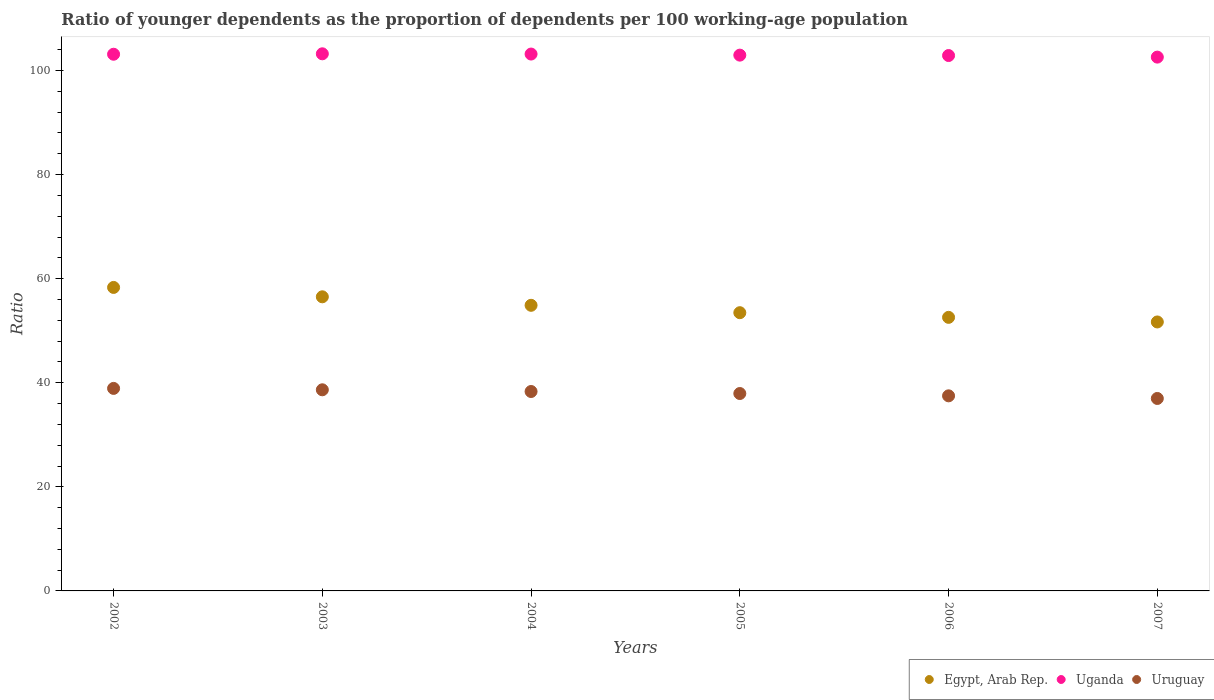Is the number of dotlines equal to the number of legend labels?
Provide a succinct answer. Yes. What is the age dependency ratio(young) in Uganda in 2006?
Offer a terse response. 102.87. Across all years, what is the maximum age dependency ratio(young) in Egypt, Arab Rep.?
Your response must be concise. 58.31. Across all years, what is the minimum age dependency ratio(young) in Egypt, Arab Rep.?
Your response must be concise. 51.68. In which year was the age dependency ratio(young) in Uruguay maximum?
Offer a very short reply. 2002. What is the total age dependency ratio(young) in Uruguay in the graph?
Make the answer very short. 228.27. What is the difference between the age dependency ratio(young) in Uganda in 2004 and that in 2005?
Offer a terse response. 0.21. What is the difference between the age dependency ratio(young) in Egypt, Arab Rep. in 2004 and the age dependency ratio(young) in Uruguay in 2007?
Give a very brief answer. 17.9. What is the average age dependency ratio(young) in Egypt, Arab Rep. per year?
Give a very brief answer. 54.57. In the year 2005, what is the difference between the age dependency ratio(young) in Uganda and age dependency ratio(young) in Uruguay?
Offer a terse response. 65.02. What is the ratio of the age dependency ratio(young) in Uganda in 2005 to that in 2007?
Keep it short and to the point. 1. What is the difference between the highest and the second highest age dependency ratio(young) in Egypt, Arab Rep.?
Make the answer very short. 1.8. What is the difference between the highest and the lowest age dependency ratio(young) in Uganda?
Your answer should be very brief. 0.63. Is the sum of the age dependency ratio(young) in Egypt, Arab Rep. in 2002 and 2006 greater than the maximum age dependency ratio(young) in Uruguay across all years?
Provide a short and direct response. Yes. Is it the case that in every year, the sum of the age dependency ratio(young) in Egypt, Arab Rep. and age dependency ratio(young) in Uganda  is greater than the age dependency ratio(young) in Uruguay?
Make the answer very short. Yes. How many dotlines are there?
Keep it short and to the point. 3. How many years are there in the graph?
Keep it short and to the point. 6. What is the difference between two consecutive major ticks on the Y-axis?
Your answer should be very brief. 20. Are the values on the major ticks of Y-axis written in scientific E-notation?
Offer a very short reply. No. How are the legend labels stacked?
Make the answer very short. Horizontal. What is the title of the graph?
Give a very brief answer. Ratio of younger dependents as the proportion of dependents per 100 working-age population. Does "Tunisia" appear as one of the legend labels in the graph?
Provide a succinct answer. No. What is the label or title of the X-axis?
Your answer should be very brief. Years. What is the label or title of the Y-axis?
Keep it short and to the point. Ratio. What is the Ratio in Egypt, Arab Rep. in 2002?
Provide a succinct answer. 58.31. What is the Ratio of Uganda in 2002?
Offer a very short reply. 103.12. What is the Ratio in Uruguay in 2002?
Offer a very short reply. 38.91. What is the Ratio of Egypt, Arab Rep. in 2003?
Provide a short and direct response. 56.51. What is the Ratio of Uganda in 2003?
Provide a succinct answer. 103.2. What is the Ratio of Uruguay in 2003?
Ensure brevity in your answer.  38.65. What is the Ratio in Egypt, Arab Rep. in 2004?
Your answer should be compact. 54.88. What is the Ratio of Uganda in 2004?
Offer a terse response. 103.16. What is the Ratio in Uruguay in 2004?
Your answer should be compact. 38.32. What is the Ratio of Egypt, Arab Rep. in 2005?
Provide a succinct answer. 53.46. What is the Ratio in Uganda in 2005?
Provide a short and direct response. 102.95. What is the Ratio in Uruguay in 2005?
Offer a very short reply. 37.93. What is the Ratio in Egypt, Arab Rep. in 2006?
Offer a terse response. 52.56. What is the Ratio in Uganda in 2006?
Provide a succinct answer. 102.87. What is the Ratio of Uruguay in 2006?
Give a very brief answer. 37.49. What is the Ratio of Egypt, Arab Rep. in 2007?
Offer a very short reply. 51.68. What is the Ratio in Uganda in 2007?
Make the answer very short. 102.57. What is the Ratio in Uruguay in 2007?
Your answer should be very brief. 36.98. Across all years, what is the maximum Ratio of Egypt, Arab Rep.?
Provide a succinct answer. 58.31. Across all years, what is the maximum Ratio in Uganda?
Give a very brief answer. 103.2. Across all years, what is the maximum Ratio of Uruguay?
Offer a terse response. 38.91. Across all years, what is the minimum Ratio in Egypt, Arab Rep.?
Offer a terse response. 51.68. Across all years, what is the minimum Ratio of Uganda?
Provide a succinct answer. 102.57. Across all years, what is the minimum Ratio of Uruguay?
Your answer should be very brief. 36.98. What is the total Ratio in Egypt, Arab Rep. in the graph?
Give a very brief answer. 327.41. What is the total Ratio in Uganda in the graph?
Your answer should be very brief. 617.87. What is the total Ratio in Uruguay in the graph?
Provide a short and direct response. 228.27. What is the difference between the Ratio of Egypt, Arab Rep. in 2002 and that in 2003?
Give a very brief answer. 1.8. What is the difference between the Ratio in Uganda in 2002 and that in 2003?
Offer a very short reply. -0.08. What is the difference between the Ratio in Uruguay in 2002 and that in 2003?
Offer a terse response. 0.27. What is the difference between the Ratio of Egypt, Arab Rep. in 2002 and that in 2004?
Make the answer very short. 3.44. What is the difference between the Ratio of Uganda in 2002 and that in 2004?
Ensure brevity in your answer.  -0.03. What is the difference between the Ratio of Uruguay in 2002 and that in 2004?
Provide a succinct answer. 0.6. What is the difference between the Ratio of Egypt, Arab Rep. in 2002 and that in 2005?
Provide a short and direct response. 4.85. What is the difference between the Ratio of Uganda in 2002 and that in 2005?
Offer a terse response. 0.17. What is the difference between the Ratio in Uruguay in 2002 and that in 2005?
Your answer should be very brief. 0.98. What is the difference between the Ratio of Egypt, Arab Rep. in 2002 and that in 2006?
Give a very brief answer. 5.75. What is the difference between the Ratio in Uganda in 2002 and that in 2006?
Provide a succinct answer. 0.25. What is the difference between the Ratio in Uruguay in 2002 and that in 2006?
Offer a very short reply. 1.43. What is the difference between the Ratio of Egypt, Arab Rep. in 2002 and that in 2007?
Keep it short and to the point. 6.63. What is the difference between the Ratio of Uganda in 2002 and that in 2007?
Keep it short and to the point. 0.55. What is the difference between the Ratio of Uruguay in 2002 and that in 2007?
Make the answer very short. 1.93. What is the difference between the Ratio of Egypt, Arab Rep. in 2003 and that in 2004?
Ensure brevity in your answer.  1.63. What is the difference between the Ratio of Uganda in 2003 and that in 2004?
Provide a succinct answer. 0.05. What is the difference between the Ratio in Uruguay in 2003 and that in 2004?
Provide a short and direct response. 0.33. What is the difference between the Ratio of Egypt, Arab Rep. in 2003 and that in 2005?
Offer a terse response. 3.05. What is the difference between the Ratio of Uganda in 2003 and that in 2005?
Give a very brief answer. 0.26. What is the difference between the Ratio of Uruguay in 2003 and that in 2005?
Your answer should be very brief. 0.72. What is the difference between the Ratio of Egypt, Arab Rep. in 2003 and that in 2006?
Offer a very short reply. 3.95. What is the difference between the Ratio in Uganda in 2003 and that in 2006?
Offer a very short reply. 0.33. What is the difference between the Ratio of Uruguay in 2003 and that in 2006?
Ensure brevity in your answer.  1.16. What is the difference between the Ratio of Egypt, Arab Rep. in 2003 and that in 2007?
Ensure brevity in your answer.  4.83. What is the difference between the Ratio of Uganda in 2003 and that in 2007?
Give a very brief answer. 0.63. What is the difference between the Ratio in Uruguay in 2003 and that in 2007?
Offer a very short reply. 1.67. What is the difference between the Ratio in Egypt, Arab Rep. in 2004 and that in 2005?
Offer a very short reply. 1.42. What is the difference between the Ratio in Uganda in 2004 and that in 2005?
Your answer should be compact. 0.21. What is the difference between the Ratio in Uruguay in 2004 and that in 2005?
Make the answer very short. 0.39. What is the difference between the Ratio in Egypt, Arab Rep. in 2004 and that in 2006?
Provide a succinct answer. 2.31. What is the difference between the Ratio of Uganda in 2004 and that in 2006?
Offer a terse response. 0.28. What is the difference between the Ratio of Uruguay in 2004 and that in 2006?
Provide a succinct answer. 0.83. What is the difference between the Ratio of Egypt, Arab Rep. in 2004 and that in 2007?
Your answer should be very brief. 3.2. What is the difference between the Ratio of Uganda in 2004 and that in 2007?
Provide a short and direct response. 0.59. What is the difference between the Ratio of Uruguay in 2004 and that in 2007?
Provide a short and direct response. 1.34. What is the difference between the Ratio in Egypt, Arab Rep. in 2005 and that in 2006?
Offer a very short reply. 0.9. What is the difference between the Ratio of Uganda in 2005 and that in 2006?
Offer a very short reply. 0.08. What is the difference between the Ratio in Uruguay in 2005 and that in 2006?
Your response must be concise. 0.45. What is the difference between the Ratio of Egypt, Arab Rep. in 2005 and that in 2007?
Offer a very short reply. 1.78. What is the difference between the Ratio of Uganda in 2005 and that in 2007?
Make the answer very short. 0.38. What is the difference between the Ratio in Uruguay in 2005 and that in 2007?
Your response must be concise. 0.95. What is the difference between the Ratio in Egypt, Arab Rep. in 2006 and that in 2007?
Make the answer very short. 0.88. What is the difference between the Ratio in Uganda in 2006 and that in 2007?
Keep it short and to the point. 0.3. What is the difference between the Ratio of Uruguay in 2006 and that in 2007?
Your answer should be compact. 0.51. What is the difference between the Ratio in Egypt, Arab Rep. in 2002 and the Ratio in Uganda in 2003?
Provide a short and direct response. -44.89. What is the difference between the Ratio in Egypt, Arab Rep. in 2002 and the Ratio in Uruguay in 2003?
Your answer should be compact. 19.67. What is the difference between the Ratio in Uganda in 2002 and the Ratio in Uruguay in 2003?
Your response must be concise. 64.48. What is the difference between the Ratio in Egypt, Arab Rep. in 2002 and the Ratio in Uganda in 2004?
Provide a succinct answer. -44.84. What is the difference between the Ratio in Egypt, Arab Rep. in 2002 and the Ratio in Uruguay in 2004?
Offer a terse response. 20. What is the difference between the Ratio of Uganda in 2002 and the Ratio of Uruguay in 2004?
Your response must be concise. 64.8. What is the difference between the Ratio in Egypt, Arab Rep. in 2002 and the Ratio in Uganda in 2005?
Keep it short and to the point. -44.63. What is the difference between the Ratio in Egypt, Arab Rep. in 2002 and the Ratio in Uruguay in 2005?
Make the answer very short. 20.38. What is the difference between the Ratio of Uganda in 2002 and the Ratio of Uruguay in 2005?
Your response must be concise. 65.19. What is the difference between the Ratio in Egypt, Arab Rep. in 2002 and the Ratio in Uganda in 2006?
Offer a terse response. -44.56. What is the difference between the Ratio of Egypt, Arab Rep. in 2002 and the Ratio of Uruguay in 2006?
Ensure brevity in your answer.  20.83. What is the difference between the Ratio of Uganda in 2002 and the Ratio of Uruguay in 2006?
Offer a terse response. 65.64. What is the difference between the Ratio in Egypt, Arab Rep. in 2002 and the Ratio in Uganda in 2007?
Your response must be concise. -44.26. What is the difference between the Ratio in Egypt, Arab Rep. in 2002 and the Ratio in Uruguay in 2007?
Offer a terse response. 21.33. What is the difference between the Ratio of Uganda in 2002 and the Ratio of Uruguay in 2007?
Offer a terse response. 66.14. What is the difference between the Ratio of Egypt, Arab Rep. in 2003 and the Ratio of Uganda in 2004?
Offer a terse response. -46.64. What is the difference between the Ratio of Egypt, Arab Rep. in 2003 and the Ratio of Uruguay in 2004?
Provide a short and direct response. 18.2. What is the difference between the Ratio in Uganda in 2003 and the Ratio in Uruguay in 2004?
Offer a terse response. 64.89. What is the difference between the Ratio of Egypt, Arab Rep. in 2003 and the Ratio of Uganda in 2005?
Make the answer very short. -46.44. What is the difference between the Ratio in Egypt, Arab Rep. in 2003 and the Ratio in Uruguay in 2005?
Offer a very short reply. 18.58. What is the difference between the Ratio in Uganda in 2003 and the Ratio in Uruguay in 2005?
Give a very brief answer. 65.27. What is the difference between the Ratio of Egypt, Arab Rep. in 2003 and the Ratio of Uganda in 2006?
Keep it short and to the point. -46.36. What is the difference between the Ratio of Egypt, Arab Rep. in 2003 and the Ratio of Uruguay in 2006?
Provide a succinct answer. 19.03. What is the difference between the Ratio of Uganda in 2003 and the Ratio of Uruguay in 2006?
Your answer should be very brief. 65.72. What is the difference between the Ratio in Egypt, Arab Rep. in 2003 and the Ratio in Uganda in 2007?
Keep it short and to the point. -46.06. What is the difference between the Ratio in Egypt, Arab Rep. in 2003 and the Ratio in Uruguay in 2007?
Give a very brief answer. 19.53. What is the difference between the Ratio of Uganda in 2003 and the Ratio of Uruguay in 2007?
Offer a terse response. 66.22. What is the difference between the Ratio of Egypt, Arab Rep. in 2004 and the Ratio of Uganda in 2005?
Provide a short and direct response. -48.07. What is the difference between the Ratio of Egypt, Arab Rep. in 2004 and the Ratio of Uruguay in 2005?
Your answer should be very brief. 16.95. What is the difference between the Ratio of Uganda in 2004 and the Ratio of Uruguay in 2005?
Provide a succinct answer. 65.23. What is the difference between the Ratio in Egypt, Arab Rep. in 2004 and the Ratio in Uganda in 2006?
Ensure brevity in your answer.  -47.99. What is the difference between the Ratio of Egypt, Arab Rep. in 2004 and the Ratio of Uruguay in 2006?
Ensure brevity in your answer.  17.39. What is the difference between the Ratio in Uganda in 2004 and the Ratio in Uruguay in 2006?
Your answer should be very brief. 65.67. What is the difference between the Ratio in Egypt, Arab Rep. in 2004 and the Ratio in Uganda in 2007?
Offer a terse response. -47.69. What is the difference between the Ratio in Egypt, Arab Rep. in 2004 and the Ratio in Uruguay in 2007?
Offer a terse response. 17.9. What is the difference between the Ratio of Uganda in 2004 and the Ratio of Uruguay in 2007?
Ensure brevity in your answer.  66.18. What is the difference between the Ratio of Egypt, Arab Rep. in 2005 and the Ratio of Uganda in 2006?
Offer a very short reply. -49.41. What is the difference between the Ratio of Egypt, Arab Rep. in 2005 and the Ratio of Uruguay in 2006?
Make the answer very short. 15.98. What is the difference between the Ratio in Uganda in 2005 and the Ratio in Uruguay in 2006?
Offer a terse response. 65.46. What is the difference between the Ratio in Egypt, Arab Rep. in 2005 and the Ratio in Uganda in 2007?
Offer a terse response. -49.11. What is the difference between the Ratio in Egypt, Arab Rep. in 2005 and the Ratio in Uruguay in 2007?
Give a very brief answer. 16.48. What is the difference between the Ratio of Uganda in 2005 and the Ratio of Uruguay in 2007?
Offer a terse response. 65.97. What is the difference between the Ratio in Egypt, Arab Rep. in 2006 and the Ratio in Uganda in 2007?
Provide a short and direct response. -50. What is the difference between the Ratio in Egypt, Arab Rep. in 2006 and the Ratio in Uruguay in 2007?
Your response must be concise. 15.58. What is the difference between the Ratio in Uganda in 2006 and the Ratio in Uruguay in 2007?
Provide a short and direct response. 65.89. What is the average Ratio of Egypt, Arab Rep. per year?
Provide a short and direct response. 54.57. What is the average Ratio in Uganda per year?
Keep it short and to the point. 102.98. What is the average Ratio in Uruguay per year?
Keep it short and to the point. 38.05. In the year 2002, what is the difference between the Ratio in Egypt, Arab Rep. and Ratio in Uganda?
Give a very brief answer. -44.81. In the year 2002, what is the difference between the Ratio in Egypt, Arab Rep. and Ratio in Uruguay?
Your answer should be compact. 19.4. In the year 2002, what is the difference between the Ratio in Uganda and Ratio in Uruguay?
Your answer should be very brief. 64.21. In the year 2003, what is the difference between the Ratio in Egypt, Arab Rep. and Ratio in Uganda?
Offer a terse response. -46.69. In the year 2003, what is the difference between the Ratio of Egypt, Arab Rep. and Ratio of Uruguay?
Your answer should be very brief. 17.87. In the year 2003, what is the difference between the Ratio of Uganda and Ratio of Uruguay?
Offer a terse response. 64.56. In the year 2004, what is the difference between the Ratio in Egypt, Arab Rep. and Ratio in Uganda?
Provide a succinct answer. -48.28. In the year 2004, what is the difference between the Ratio in Egypt, Arab Rep. and Ratio in Uruguay?
Provide a short and direct response. 16.56. In the year 2004, what is the difference between the Ratio in Uganda and Ratio in Uruguay?
Ensure brevity in your answer.  64.84. In the year 2005, what is the difference between the Ratio of Egypt, Arab Rep. and Ratio of Uganda?
Ensure brevity in your answer.  -49.49. In the year 2005, what is the difference between the Ratio of Egypt, Arab Rep. and Ratio of Uruguay?
Ensure brevity in your answer.  15.53. In the year 2005, what is the difference between the Ratio of Uganda and Ratio of Uruguay?
Your answer should be very brief. 65.02. In the year 2006, what is the difference between the Ratio in Egypt, Arab Rep. and Ratio in Uganda?
Provide a short and direct response. -50.31. In the year 2006, what is the difference between the Ratio in Egypt, Arab Rep. and Ratio in Uruguay?
Offer a very short reply. 15.08. In the year 2006, what is the difference between the Ratio of Uganda and Ratio of Uruguay?
Provide a succinct answer. 65.39. In the year 2007, what is the difference between the Ratio in Egypt, Arab Rep. and Ratio in Uganda?
Your response must be concise. -50.89. In the year 2007, what is the difference between the Ratio in Egypt, Arab Rep. and Ratio in Uruguay?
Your answer should be very brief. 14.7. In the year 2007, what is the difference between the Ratio in Uganda and Ratio in Uruguay?
Provide a succinct answer. 65.59. What is the ratio of the Ratio of Egypt, Arab Rep. in 2002 to that in 2003?
Give a very brief answer. 1.03. What is the ratio of the Ratio in Uganda in 2002 to that in 2003?
Provide a succinct answer. 1. What is the ratio of the Ratio of Uruguay in 2002 to that in 2003?
Give a very brief answer. 1.01. What is the ratio of the Ratio of Egypt, Arab Rep. in 2002 to that in 2004?
Make the answer very short. 1.06. What is the ratio of the Ratio in Uruguay in 2002 to that in 2004?
Offer a terse response. 1.02. What is the ratio of the Ratio in Egypt, Arab Rep. in 2002 to that in 2005?
Offer a very short reply. 1.09. What is the ratio of the Ratio in Uruguay in 2002 to that in 2005?
Your response must be concise. 1.03. What is the ratio of the Ratio in Egypt, Arab Rep. in 2002 to that in 2006?
Provide a succinct answer. 1.11. What is the ratio of the Ratio of Uganda in 2002 to that in 2006?
Your response must be concise. 1. What is the ratio of the Ratio in Uruguay in 2002 to that in 2006?
Your answer should be very brief. 1.04. What is the ratio of the Ratio in Egypt, Arab Rep. in 2002 to that in 2007?
Offer a terse response. 1.13. What is the ratio of the Ratio in Uganda in 2002 to that in 2007?
Give a very brief answer. 1.01. What is the ratio of the Ratio of Uruguay in 2002 to that in 2007?
Your answer should be very brief. 1.05. What is the ratio of the Ratio in Egypt, Arab Rep. in 2003 to that in 2004?
Offer a terse response. 1.03. What is the ratio of the Ratio of Uruguay in 2003 to that in 2004?
Provide a short and direct response. 1.01. What is the ratio of the Ratio of Egypt, Arab Rep. in 2003 to that in 2005?
Give a very brief answer. 1.06. What is the ratio of the Ratio of Uruguay in 2003 to that in 2005?
Make the answer very short. 1.02. What is the ratio of the Ratio in Egypt, Arab Rep. in 2003 to that in 2006?
Give a very brief answer. 1.08. What is the ratio of the Ratio of Uruguay in 2003 to that in 2006?
Provide a short and direct response. 1.03. What is the ratio of the Ratio of Egypt, Arab Rep. in 2003 to that in 2007?
Provide a succinct answer. 1.09. What is the ratio of the Ratio in Uganda in 2003 to that in 2007?
Make the answer very short. 1.01. What is the ratio of the Ratio of Uruguay in 2003 to that in 2007?
Give a very brief answer. 1.04. What is the ratio of the Ratio of Egypt, Arab Rep. in 2004 to that in 2005?
Your answer should be compact. 1.03. What is the ratio of the Ratio in Uganda in 2004 to that in 2005?
Ensure brevity in your answer.  1. What is the ratio of the Ratio in Uruguay in 2004 to that in 2005?
Offer a terse response. 1.01. What is the ratio of the Ratio of Egypt, Arab Rep. in 2004 to that in 2006?
Make the answer very short. 1.04. What is the ratio of the Ratio of Uganda in 2004 to that in 2006?
Your answer should be compact. 1. What is the ratio of the Ratio of Uruguay in 2004 to that in 2006?
Provide a short and direct response. 1.02. What is the ratio of the Ratio of Egypt, Arab Rep. in 2004 to that in 2007?
Provide a succinct answer. 1.06. What is the ratio of the Ratio in Uganda in 2004 to that in 2007?
Offer a very short reply. 1.01. What is the ratio of the Ratio in Uruguay in 2004 to that in 2007?
Make the answer very short. 1.04. What is the ratio of the Ratio of Uruguay in 2005 to that in 2006?
Provide a succinct answer. 1.01. What is the ratio of the Ratio in Egypt, Arab Rep. in 2005 to that in 2007?
Your answer should be very brief. 1.03. What is the ratio of the Ratio in Uruguay in 2005 to that in 2007?
Offer a very short reply. 1.03. What is the ratio of the Ratio of Egypt, Arab Rep. in 2006 to that in 2007?
Your answer should be compact. 1.02. What is the ratio of the Ratio of Uruguay in 2006 to that in 2007?
Provide a succinct answer. 1.01. What is the difference between the highest and the second highest Ratio in Egypt, Arab Rep.?
Your answer should be compact. 1.8. What is the difference between the highest and the second highest Ratio in Uganda?
Your answer should be compact. 0.05. What is the difference between the highest and the second highest Ratio of Uruguay?
Offer a very short reply. 0.27. What is the difference between the highest and the lowest Ratio of Egypt, Arab Rep.?
Offer a terse response. 6.63. What is the difference between the highest and the lowest Ratio in Uganda?
Ensure brevity in your answer.  0.63. What is the difference between the highest and the lowest Ratio in Uruguay?
Your answer should be compact. 1.93. 